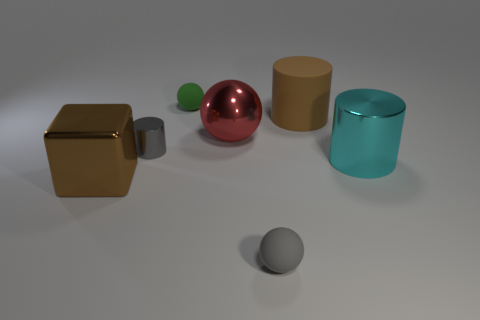Subtract all shiny cylinders. How many cylinders are left? 1 Add 1 brown objects. How many objects exist? 8 Subtract all green balls. How many balls are left? 2 Subtract all blocks. How many objects are left? 6 Subtract all green cubes. Subtract all gray spheres. How many cubes are left? 1 Subtract all gray blocks. How many brown balls are left? 0 Subtract all brown objects. Subtract all large objects. How many objects are left? 1 Add 5 big matte objects. How many big matte objects are left? 6 Add 7 red cubes. How many red cubes exist? 7 Subtract 1 cyan cylinders. How many objects are left? 6 